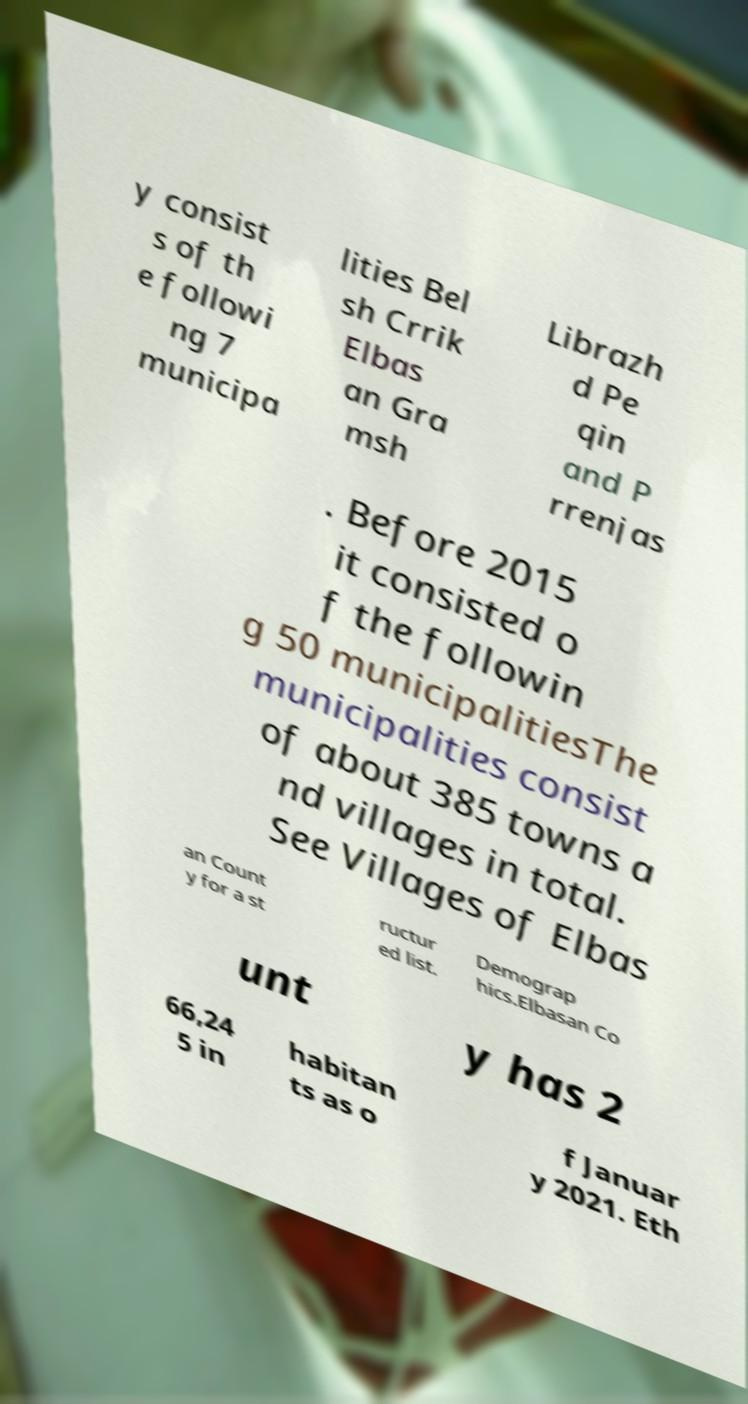What messages or text are displayed in this image? I need them in a readable, typed format. y consist s of th e followi ng 7 municipa lities Bel sh Crrik Elbas an Gra msh Librazh d Pe qin and P rrenjas . Before 2015 it consisted o f the followin g 50 municipalitiesThe municipalities consist of about 385 towns a nd villages in total. See Villages of Elbas an Count y for a st ructur ed list. Demograp hics.Elbasan Co unt y has 2 66,24 5 in habitan ts as o f Januar y 2021. Eth 